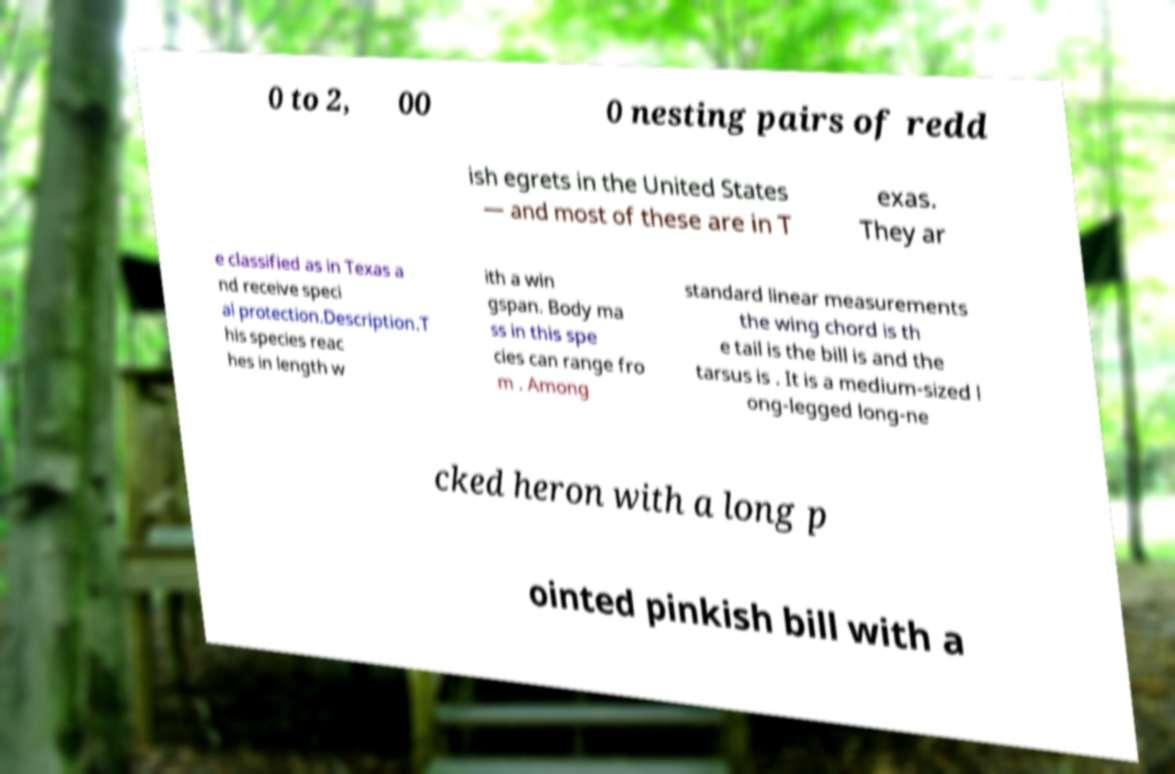Can you accurately transcribe the text from the provided image for me? 0 to 2, 00 0 nesting pairs of redd ish egrets in the United States — and most of these are in T exas. They ar e classified as in Texas a nd receive speci al protection.Description.T his species reac hes in length w ith a win gspan. Body ma ss in this spe cies can range fro m . Among standard linear measurements the wing chord is th e tail is the bill is and the tarsus is . It is a medium-sized l ong-legged long-ne cked heron with a long p ointed pinkish bill with a 